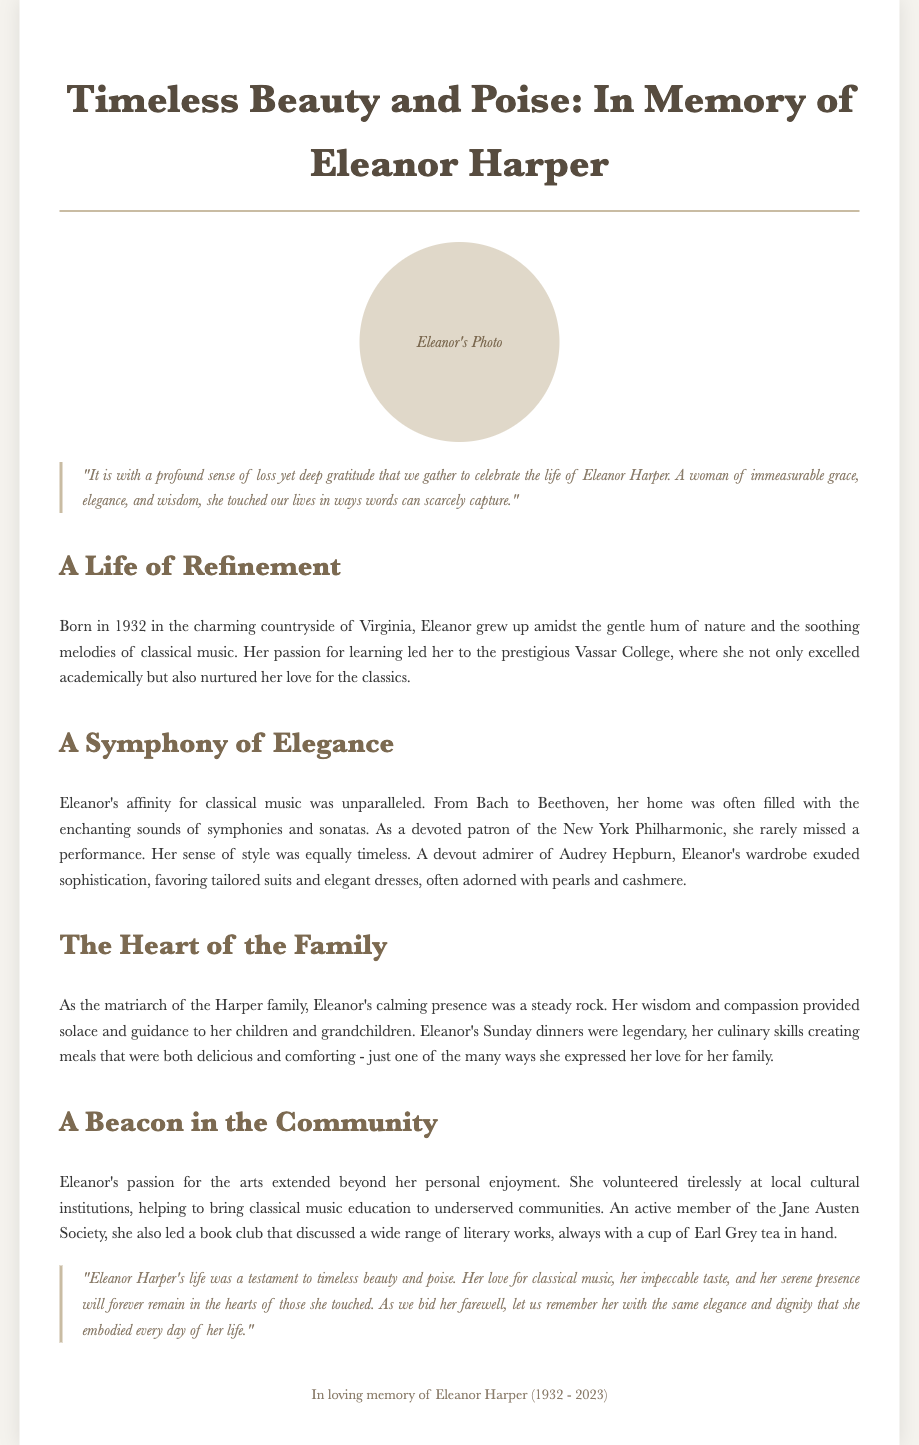What is the title of the eulogy? The title of the eulogy is found at the top of the document.
Answer: Timeless Beauty and Poise: In Memory of Eleanor Harper What year was Eleanor born? Eleanor's birth year is mentioned in the document under her biography.
Answer: 1932 What prestigious college did Eleanor attend? The document specifies the name of the college she attended during her education.
Answer: Vassar College What was Eleanor's favorite genre of music? The eulogy highlights Eleanor's musical preferences.
Answer: Classical music Which arts organization did Eleanor support? The eulogy mentions her involvement with a notable music institution.
Answer: New York Philharmonic What type of tea did Eleanor enjoy? The closing section of the eulogy details Eleanor's preferences during her book club meetings.
Answer: Earl Grey tea How did Eleanor express her love for her family? The document describes how Eleanor's culinary skills were a way of expressing love.
Answer: Sunday dinners What literary society was Eleanor an active member of? The document mentions the society she participated in related to literature.
Answer: Jane Austen Society 